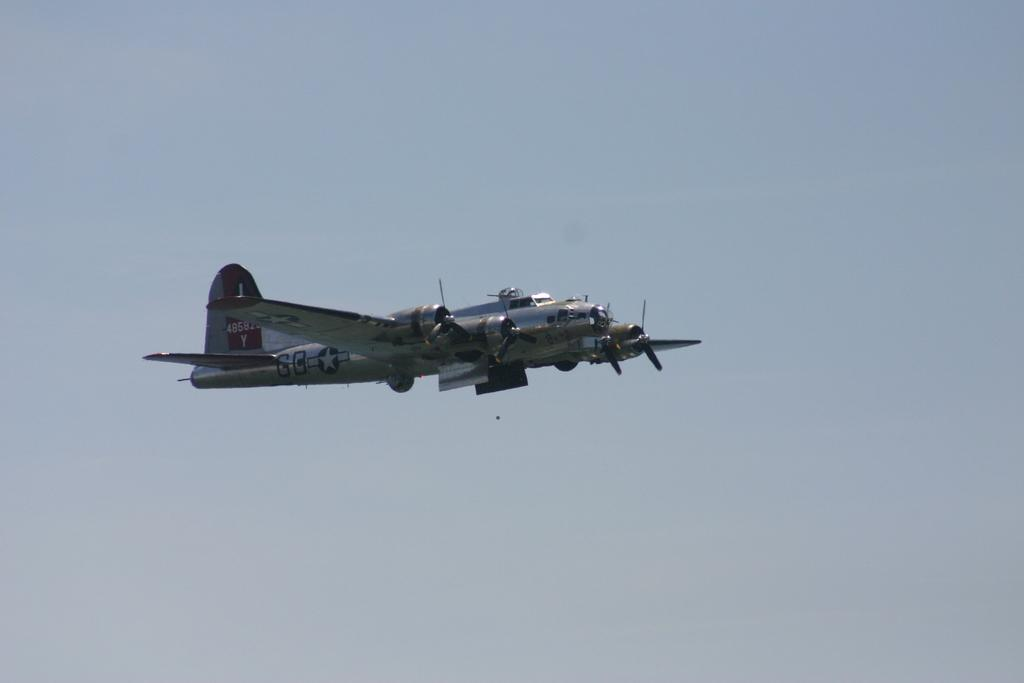<image>
Relay a brief, clear account of the picture shown. The letter Y is on the tail of a plane flying in the air. 